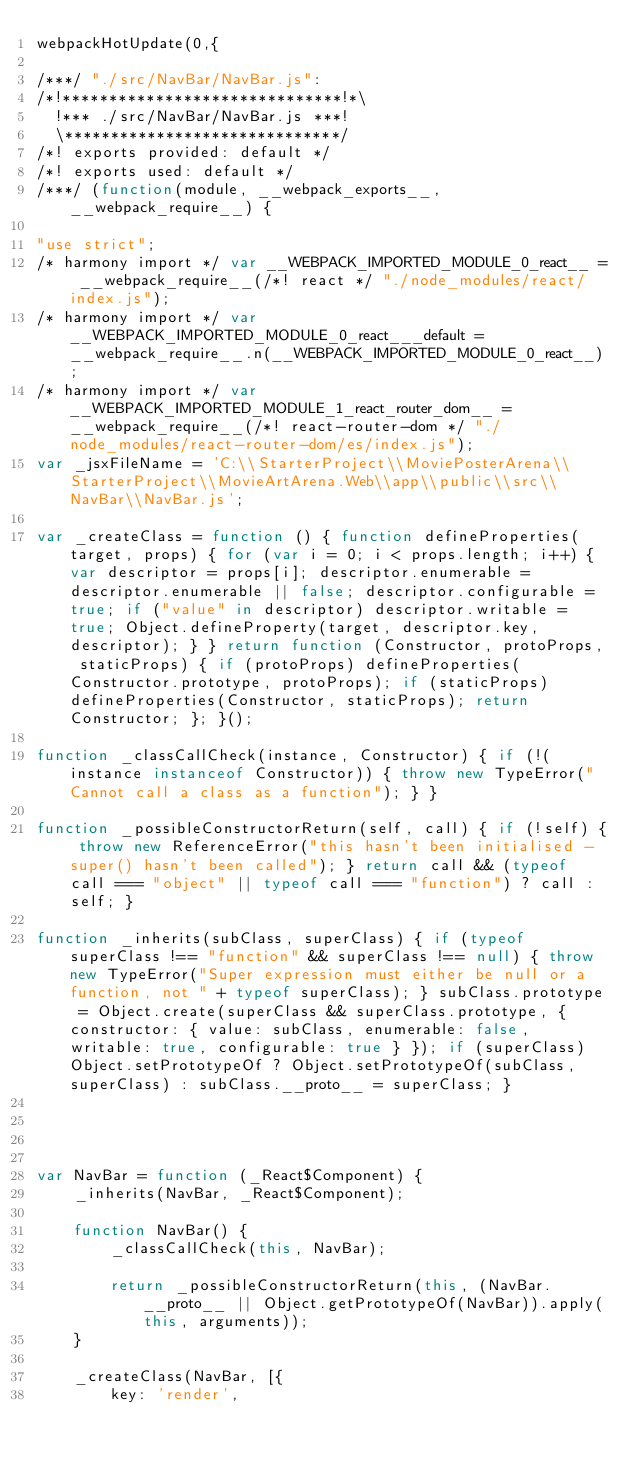<code> <loc_0><loc_0><loc_500><loc_500><_JavaScript_>webpackHotUpdate(0,{

/***/ "./src/NavBar/NavBar.js":
/*!******************************!*\
  !*** ./src/NavBar/NavBar.js ***!
  \******************************/
/*! exports provided: default */
/*! exports used: default */
/***/ (function(module, __webpack_exports__, __webpack_require__) {

"use strict";
/* harmony import */ var __WEBPACK_IMPORTED_MODULE_0_react__ = __webpack_require__(/*! react */ "./node_modules/react/index.js");
/* harmony import */ var __WEBPACK_IMPORTED_MODULE_0_react___default = __webpack_require__.n(__WEBPACK_IMPORTED_MODULE_0_react__);
/* harmony import */ var __WEBPACK_IMPORTED_MODULE_1_react_router_dom__ = __webpack_require__(/*! react-router-dom */ "./node_modules/react-router-dom/es/index.js");
var _jsxFileName = 'C:\\StarterProject\\MoviePosterArena\\StarterProject\\MovieArtArena.Web\\app\\public\\src\\NavBar\\NavBar.js';

var _createClass = function () { function defineProperties(target, props) { for (var i = 0; i < props.length; i++) { var descriptor = props[i]; descriptor.enumerable = descriptor.enumerable || false; descriptor.configurable = true; if ("value" in descriptor) descriptor.writable = true; Object.defineProperty(target, descriptor.key, descriptor); } } return function (Constructor, protoProps, staticProps) { if (protoProps) defineProperties(Constructor.prototype, protoProps); if (staticProps) defineProperties(Constructor, staticProps); return Constructor; }; }();

function _classCallCheck(instance, Constructor) { if (!(instance instanceof Constructor)) { throw new TypeError("Cannot call a class as a function"); } }

function _possibleConstructorReturn(self, call) { if (!self) { throw new ReferenceError("this hasn't been initialised - super() hasn't been called"); } return call && (typeof call === "object" || typeof call === "function") ? call : self; }

function _inherits(subClass, superClass) { if (typeof superClass !== "function" && superClass !== null) { throw new TypeError("Super expression must either be null or a function, not " + typeof superClass); } subClass.prototype = Object.create(superClass && superClass.prototype, { constructor: { value: subClass, enumerable: false, writable: true, configurable: true } }); if (superClass) Object.setPrototypeOf ? Object.setPrototypeOf(subClass, superClass) : subClass.__proto__ = superClass; }




var NavBar = function (_React$Component) {
    _inherits(NavBar, _React$Component);

    function NavBar() {
        _classCallCheck(this, NavBar);

        return _possibleConstructorReturn(this, (NavBar.__proto__ || Object.getPrototypeOf(NavBar)).apply(this, arguments));
    }

    _createClass(NavBar, [{
        key: 'render',</code> 